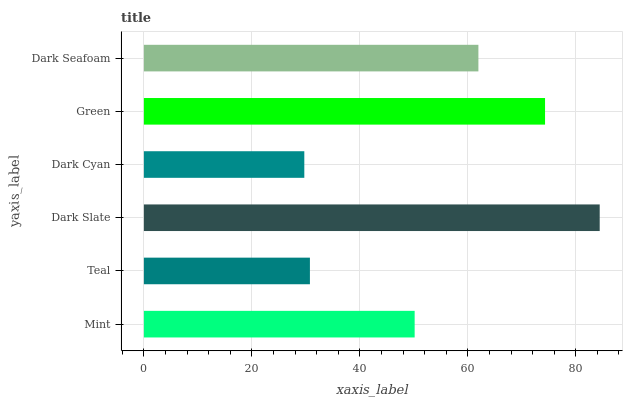Is Dark Cyan the minimum?
Answer yes or no. Yes. Is Dark Slate the maximum?
Answer yes or no. Yes. Is Teal the minimum?
Answer yes or no. No. Is Teal the maximum?
Answer yes or no. No. Is Mint greater than Teal?
Answer yes or no. Yes. Is Teal less than Mint?
Answer yes or no. Yes. Is Teal greater than Mint?
Answer yes or no. No. Is Mint less than Teal?
Answer yes or no. No. Is Dark Seafoam the high median?
Answer yes or no. Yes. Is Mint the low median?
Answer yes or no. Yes. Is Green the high median?
Answer yes or no. No. Is Dark Slate the low median?
Answer yes or no. No. 